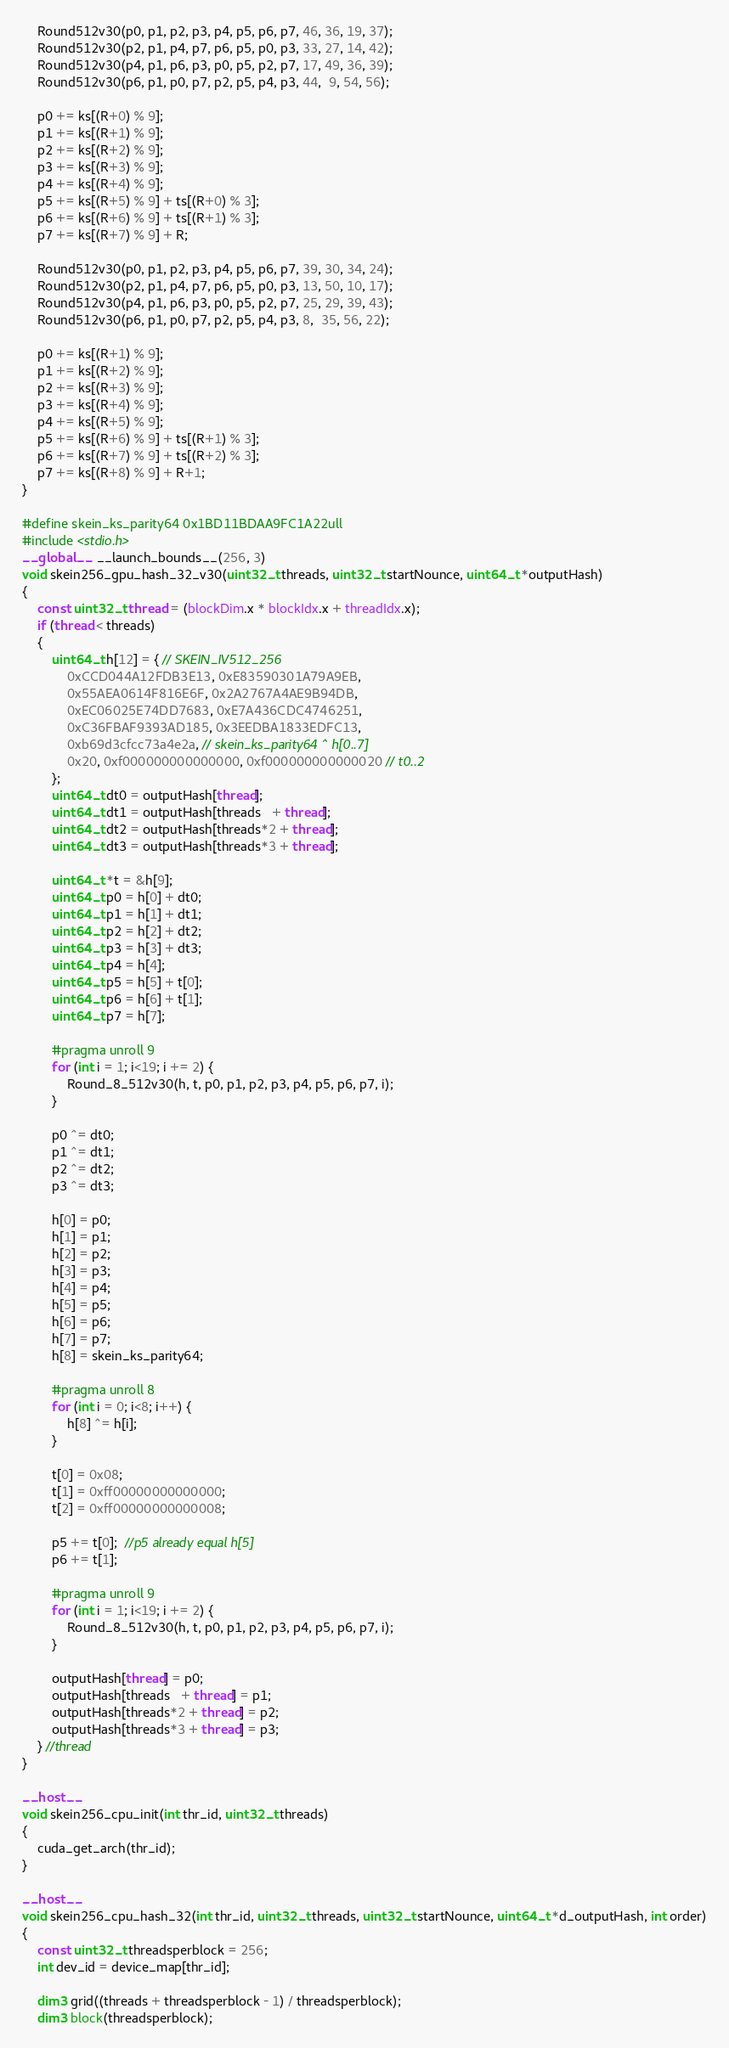<code> <loc_0><loc_0><loc_500><loc_500><_Cuda_>	Round512v30(p0, p1, p2, p3, p4, p5, p6, p7, 46, 36, 19, 37);
	Round512v30(p2, p1, p4, p7, p6, p5, p0, p3, 33, 27, 14, 42);
	Round512v30(p4, p1, p6, p3, p0, p5, p2, p7, 17, 49, 36, 39);
	Round512v30(p6, p1, p0, p7, p2, p5, p4, p3, 44,  9, 54, 56);

	p0 += ks[(R+0) % 9];
	p1 += ks[(R+1) % 9];
	p2 += ks[(R+2) % 9];
	p3 += ks[(R+3) % 9];
	p4 += ks[(R+4) % 9];
	p5 += ks[(R+5) % 9] + ts[(R+0) % 3];
	p6 += ks[(R+6) % 9] + ts[(R+1) % 3];
	p7 += ks[(R+7) % 9] + R;

	Round512v30(p0, p1, p2, p3, p4, p5, p6, p7, 39, 30, 34, 24);
	Round512v30(p2, p1, p4, p7, p6, p5, p0, p3, 13, 50, 10, 17);
	Round512v30(p4, p1, p6, p3, p0, p5, p2, p7, 25, 29, 39, 43);
	Round512v30(p6, p1, p0, p7, p2, p5, p4, p3, 8,  35, 56, 22);

	p0 += ks[(R+1) % 9];
	p1 += ks[(R+2) % 9];
	p2 += ks[(R+3) % 9];
	p3 += ks[(R+4) % 9];
	p4 += ks[(R+5) % 9];
	p5 += ks[(R+6) % 9] + ts[(R+1) % 3];
	p6 += ks[(R+7) % 9] + ts[(R+2) % 3];
	p7 += ks[(R+8) % 9] + R+1;
}

#define skein_ks_parity64 0x1BD11BDAA9FC1A22ull
#include <stdio.h>
__global__  __launch_bounds__(256, 3)
void skein256_gpu_hash_32_v30(uint32_t threads, uint32_t startNounce, uint64_t *outputHash)
{
	const uint32_t thread = (blockDim.x * blockIdx.x + threadIdx.x);
	if (thread < threads)
	{
		uint64_t h[12] = { // SKEIN_IV512_256
			0xCCD044A12FDB3E13, 0xE83590301A79A9EB,
			0x55AEA0614F816E6F, 0x2A2767A4AE9B94DB,
			0xEC06025E74DD7683, 0xE7A436CDC4746251,
			0xC36FBAF9393AD185, 0x3EEDBA1833EDFC13,
			0xb69d3cfcc73a4e2a, // skein_ks_parity64 ^ h[0..7]
			0x20, 0xf000000000000000, 0xf000000000000020 // t0..2
		};
		uint64_t dt0 = outputHash[thread];
		uint64_t dt1 = outputHash[threads   + thread];
		uint64_t dt2 = outputHash[threads*2 + thread];
		uint64_t dt3 = outputHash[threads*3 + thread];

		uint64_t *t = &h[9];
		uint64_t p0 = h[0] + dt0;
		uint64_t p1 = h[1] + dt1;
		uint64_t p2 = h[2] + dt2;
		uint64_t p3 = h[3] + dt3;
		uint64_t p4 = h[4];
		uint64_t p5 = h[5] + t[0];
		uint64_t p6 = h[6] + t[1];
		uint64_t p7 = h[7];

		#pragma unroll 9
		for (int i = 1; i<19; i += 2) {
			Round_8_512v30(h, t, p0, p1, p2, p3, p4, p5, p6, p7, i);
		}

		p0 ^= dt0;
		p1 ^= dt1;
		p2 ^= dt2;
		p3 ^= dt3;

		h[0] = p0;
		h[1] = p1;
		h[2] = p2;
		h[3] = p3;
		h[4] = p4;
		h[5] = p5;
		h[6] = p6;
		h[7] = p7;
		h[8] = skein_ks_parity64;

		#pragma unroll 8
		for (int i = 0; i<8; i++) {
			h[8] ^= h[i];
		}

		t[0] = 0x08;
		t[1] = 0xff00000000000000;
		t[2] = 0xff00000000000008;

		p5 += t[0];  //p5 already equal h[5]
		p6 += t[1];

		#pragma unroll 9
		for (int i = 1; i<19; i += 2) {
			Round_8_512v30(h, t, p0, p1, p2, p3, p4, p5, p6, p7, i);
		}

		outputHash[thread] = p0;
		outputHash[threads   + thread] = p1;
		outputHash[threads*2 + thread] = p2;
		outputHash[threads*3 + thread] = p3;
	} //thread
}

__host__
void skein256_cpu_init(int thr_id, uint32_t threads)
{
	cuda_get_arch(thr_id);
}

__host__
void skein256_cpu_hash_32(int thr_id, uint32_t threads, uint32_t startNounce, uint64_t *d_outputHash, int order)
{
	const uint32_t threadsperblock = 256;
	int dev_id = device_map[thr_id];

	dim3 grid((threads + threadsperblock - 1) / threadsperblock);
	dim3 block(threadsperblock);
</code> 